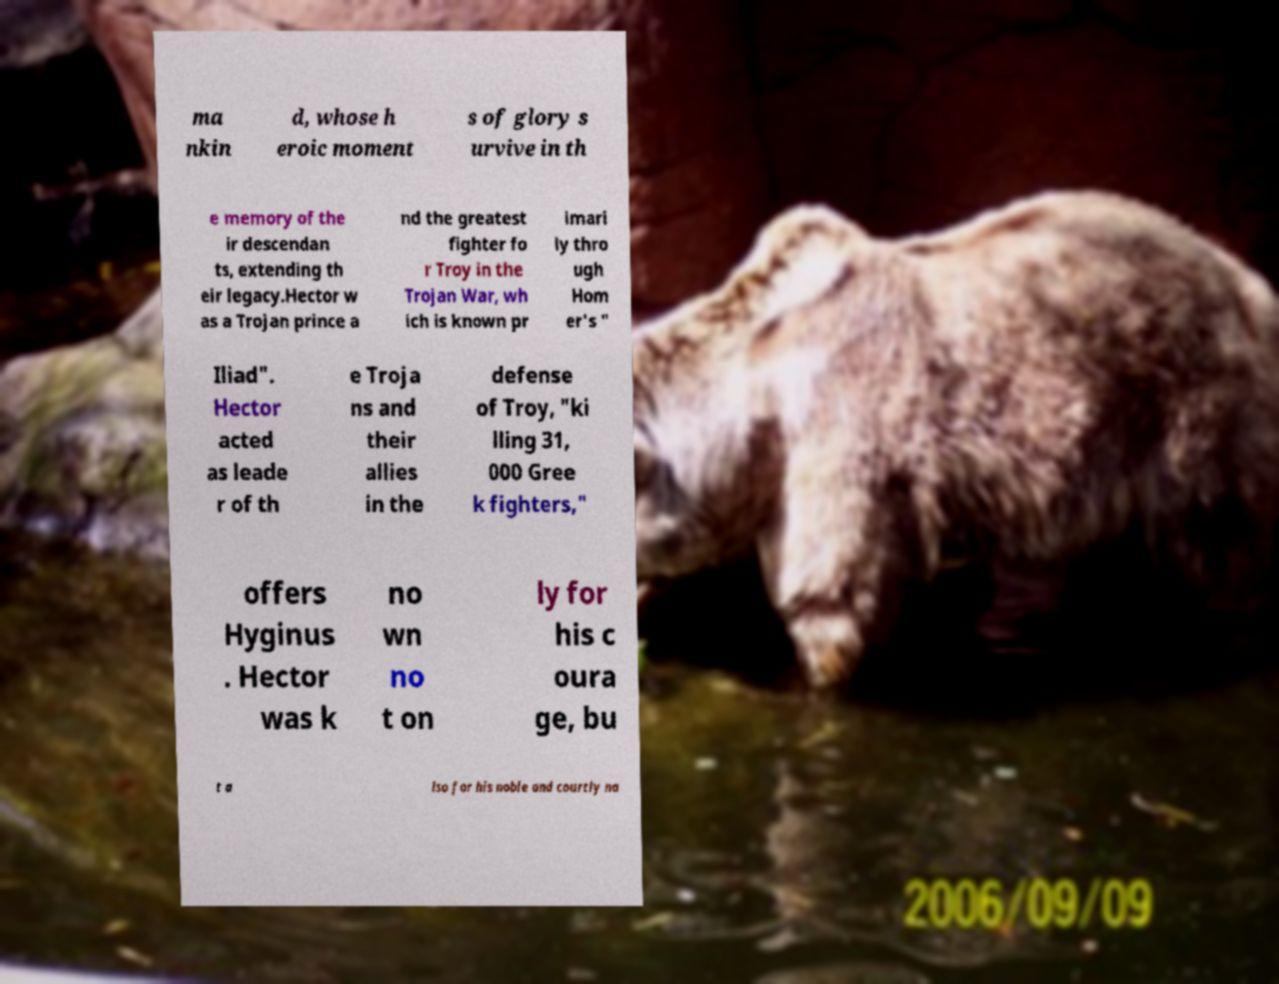What messages or text are displayed in this image? I need them in a readable, typed format. ma nkin d, whose h eroic moment s of glory s urvive in th e memory of the ir descendan ts, extending th eir legacy.Hector w as a Trojan prince a nd the greatest fighter fo r Troy in the Trojan War, wh ich is known pr imari ly thro ugh Hom er's " Iliad". Hector acted as leade r of th e Troja ns and their allies in the defense of Troy, "ki lling 31, 000 Gree k fighters," offers Hyginus . Hector was k no wn no t on ly for his c oura ge, bu t a lso for his noble and courtly na 